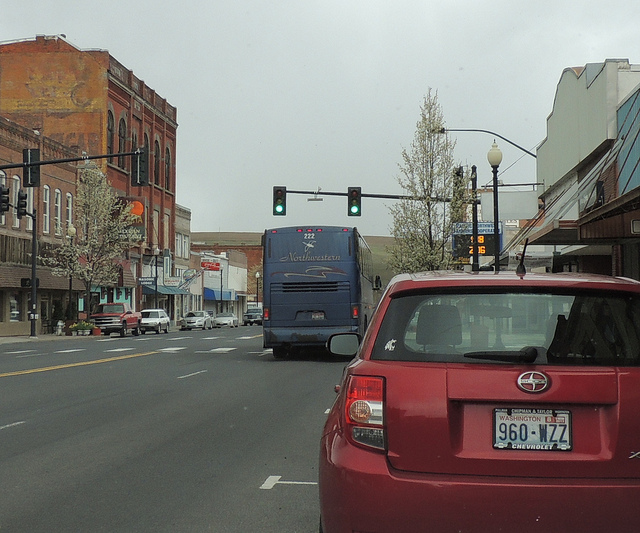<image>What animal is in the window? I don't know if there is an animal in the window. Some people suggested a dog, while others saw no animal. What is the number next to the traffic light? It is unknown what the number next to the traffic light is. It could be 2, 8, 960, 592, or 222. What animal is in the window? There is a dog in the window. What is the number next to the traffic light? I am not sure about the number next to the traffic light. It can be seen as 'unknown', '2', '960', '8', '592', '0', '222' or 'green'. 